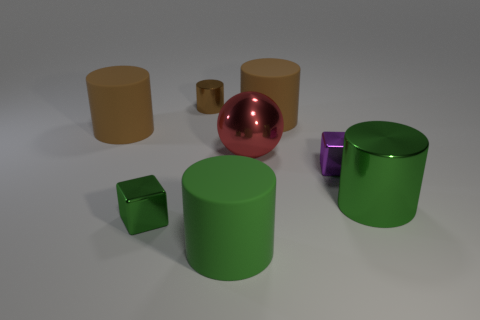Subtract all brown cylinders. How many were subtracted if there are1brown cylinders left? 2 Subtract all purple cubes. How many brown cylinders are left? 3 Subtract 2 cylinders. How many cylinders are left? 3 Subtract all green metal cylinders. How many cylinders are left? 4 Subtract all purple cylinders. Subtract all gray blocks. How many cylinders are left? 5 Add 1 red metal cylinders. How many objects exist? 9 Subtract all cylinders. How many objects are left? 3 Subtract all tiny purple shiny things. Subtract all tiny purple things. How many objects are left? 6 Add 2 tiny cylinders. How many tiny cylinders are left? 3 Add 1 big green shiny cylinders. How many big green shiny cylinders exist? 2 